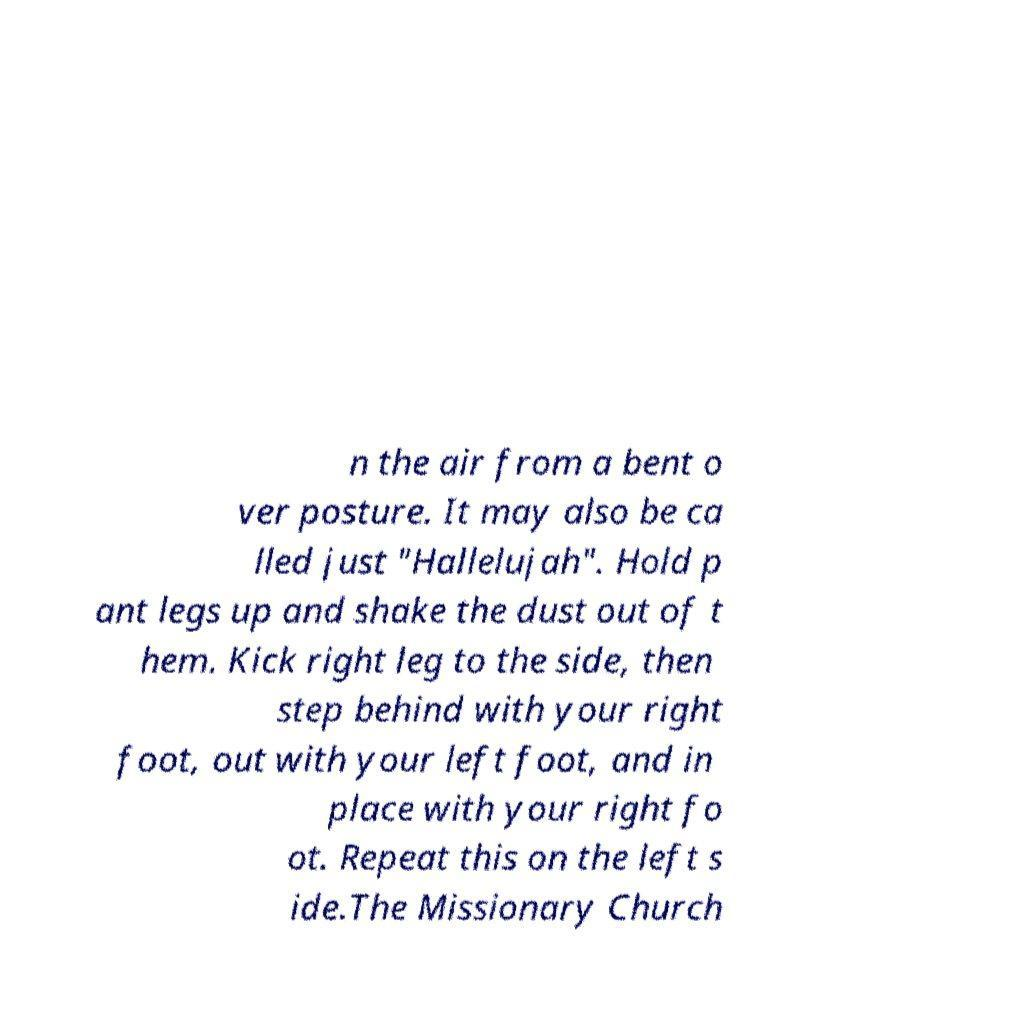For documentation purposes, I need the text within this image transcribed. Could you provide that? n the air from a bent o ver posture. It may also be ca lled just "Hallelujah". Hold p ant legs up and shake the dust out of t hem. Kick right leg to the side, then step behind with your right foot, out with your left foot, and in place with your right fo ot. Repeat this on the left s ide.The Missionary Church 